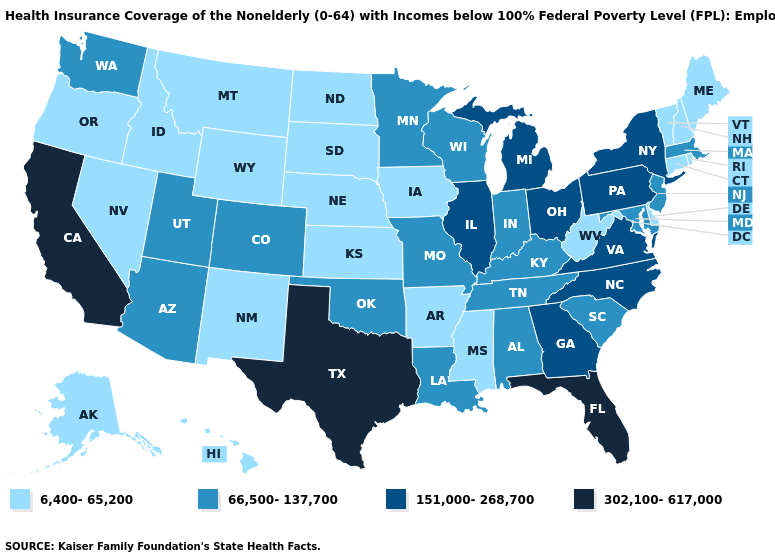What is the value of Illinois?
Write a very short answer. 151,000-268,700. What is the lowest value in the USA?
Short answer required. 6,400-65,200. Name the states that have a value in the range 302,100-617,000?
Be succinct. California, Florida, Texas. Name the states that have a value in the range 66,500-137,700?
Give a very brief answer. Alabama, Arizona, Colorado, Indiana, Kentucky, Louisiana, Maryland, Massachusetts, Minnesota, Missouri, New Jersey, Oklahoma, South Carolina, Tennessee, Utah, Washington, Wisconsin. Name the states that have a value in the range 151,000-268,700?
Answer briefly. Georgia, Illinois, Michigan, New York, North Carolina, Ohio, Pennsylvania, Virginia. What is the value of Idaho?
Be succinct. 6,400-65,200. Does Iowa have the highest value in the MidWest?
Give a very brief answer. No. What is the value of Oregon?
Write a very short answer. 6,400-65,200. Which states hav the highest value in the South?
Keep it brief. Florida, Texas. How many symbols are there in the legend?
Concise answer only. 4. Name the states that have a value in the range 151,000-268,700?
Write a very short answer. Georgia, Illinois, Michigan, New York, North Carolina, Ohio, Pennsylvania, Virginia. Name the states that have a value in the range 302,100-617,000?
Short answer required. California, Florida, Texas. Does New Jersey have the lowest value in the USA?
Give a very brief answer. No. Name the states that have a value in the range 151,000-268,700?
Be succinct. Georgia, Illinois, Michigan, New York, North Carolina, Ohio, Pennsylvania, Virginia. 